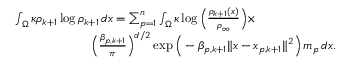<formula> <loc_0><loc_0><loc_500><loc_500>\begin{array} { r l } & { \int _ { \Omega } \kappa \rho _ { k + 1 } \log \rho _ { k + 1 } \, d x = \sum _ { p = 1 } ^ { n } \int _ { \Omega } \kappa \log \left ( \frac { \rho _ { k + 1 } ( x ) } { \rho _ { \infty } } \right ) \times } \\ & { \quad \left ( \frac { \beta _ { p , k + 1 } } { \pi } \right ) ^ { d / 2 } \exp \left ( - \beta _ { p , k + 1 } \| x - x _ { p , k + 1 } \| ^ { 2 } \right ) \, m _ { p } \, d x . } \end{array}</formula> 